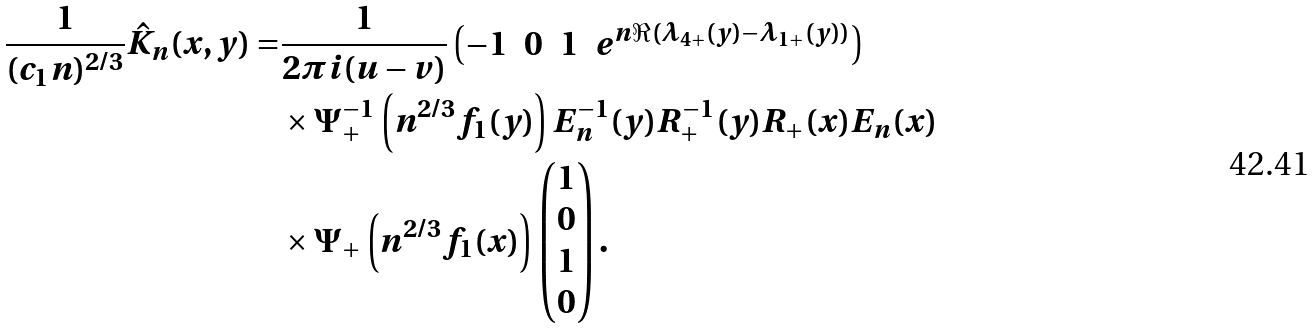Convert formula to latex. <formula><loc_0><loc_0><loc_500><loc_500>\frac { 1 } { ( c _ { 1 } n ) ^ { 2 / 3 } } \hat { K } _ { n } ( x , y ) = & \frac { 1 } { 2 \pi i ( u - v ) } \begin{pmatrix} - 1 & 0 & 1 & e ^ { n \Re ( \lambda _ { 4 + } ( y ) - \lambda _ { 1 + } ( y ) ) } \end{pmatrix} \\ & \times \Psi ^ { - 1 } _ { + } \left ( n ^ { 2 / 3 } f _ { 1 } ( y ) \right ) E _ { n } ^ { - 1 } ( y ) R _ { + } ^ { - 1 } ( y ) R _ { + } ( x ) E _ { n } ( x ) \\ & \times \Psi _ { + } \left ( n ^ { 2 / 3 } f _ { 1 } ( x ) \right ) \begin{pmatrix} 1 \\ 0 \\ 1 \\ 0 \end{pmatrix} .</formula> 